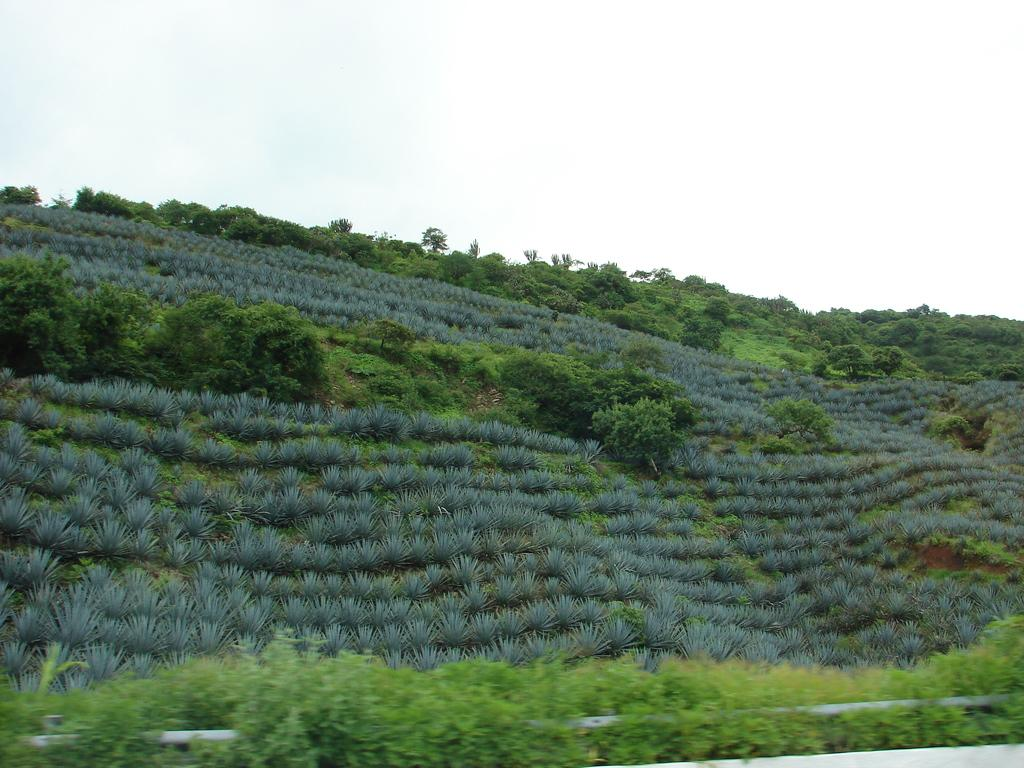What object is present in the image that connects plants? There is a pipe in the image that connects plants. What type of vegetation can be seen in the image? There are plants in the image. What can be seen in the background of the image? There are trees in the background of the image. What property is being discussed in the image? There is no discussion of a property in the image; it features a pipe connecting plants and trees in the background. How many weeks have passed since the pipe was installed in the image? The image does not provide information about when the pipe was installed, so it is impossible to determine how many weeks have passed. 